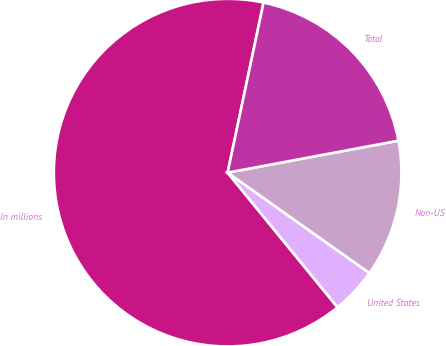<chart> <loc_0><loc_0><loc_500><loc_500><pie_chart><fcel>In millions<fcel>United States<fcel>Non-US<fcel>Total<nl><fcel>64.21%<fcel>4.3%<fcel>12.75%<fcel>18.74%<nl></chart> 